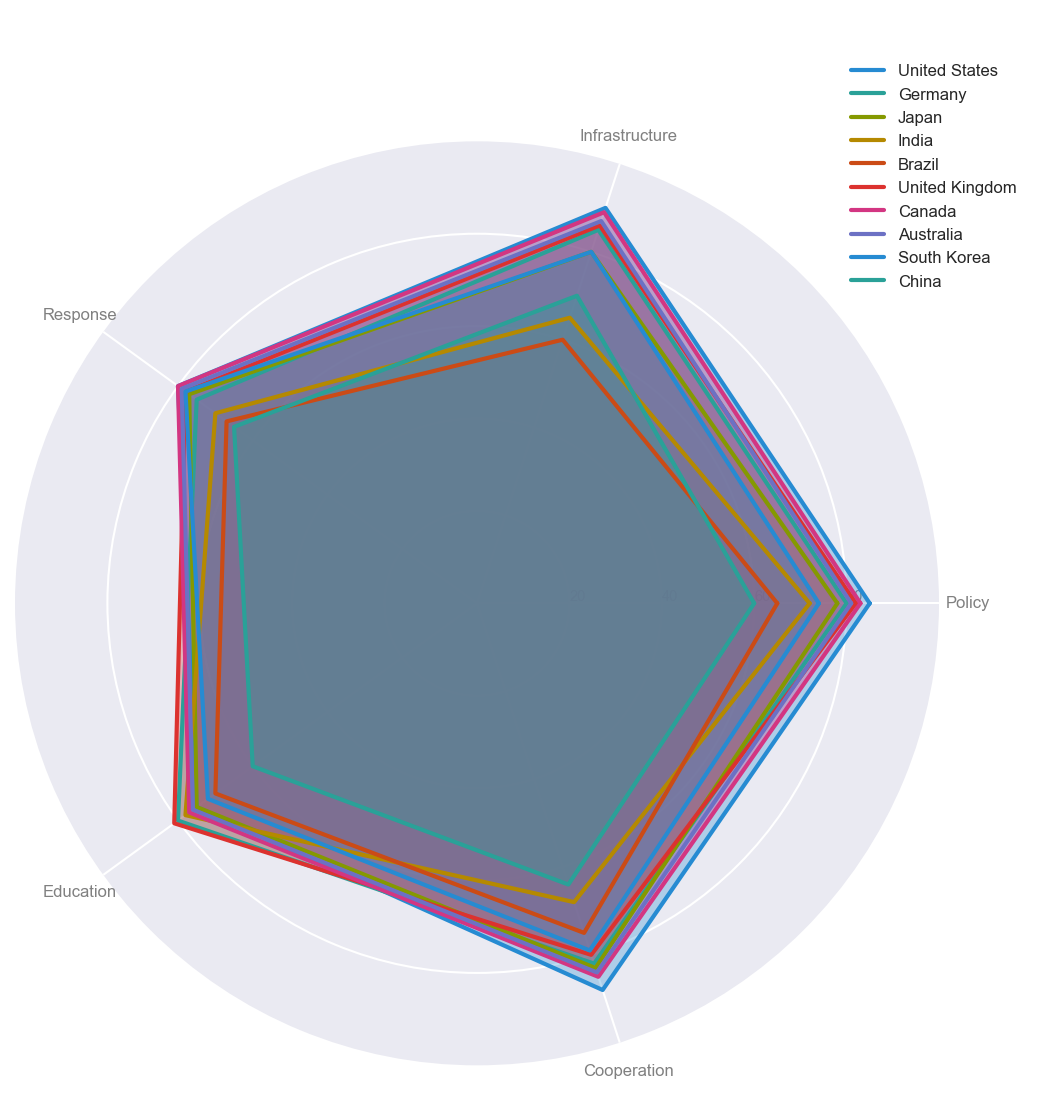Which country has the highest score in Infrastructure? According to the radar chart, the country with the highest score in Infrastructure has the longest spoke extending outwards at the "Infrastructure" axis. By observing the chart, Canada has the highest Infrastructure score.
Answer: Canada Which country scores the lowest in Policy? Identify the country with the shortest spoke on the "Policy" axis. China has the smallest value on this axis.
Answer: China What is the average Education score among all countries? Sum the Education scores of all countries and divide by the number of countries. (75 + 80 + 75 + 78 + 70 + 81 + 77+ 76 + 72 + 60) / 10 = 74.4
Answer: 74.4 Which countries have a higher Response score than Japan? Compare the scores at the "Response" axis where Japan scores 77. The countries with higher scores are United States (80), Germany (80), Canada (80), and Australia (79).
Answer: United States, Germany, Canada, Australia How does the Cooperation score of the United States compare to that of China? Observe the "Cooperation" axis for both United States and China. The United States scores 88, while China scores 64. The United States has a significantly higher Cooperation score compared to China.
Answer: United States scores higher than China What is the difference between the highest and lowest scores in the Policy category? Identify the highest and lowest scores in the Policy category by checking the "Policy" axis. The highest score is 85 (United States), and the lowest is 60 (China). The difference is 85 - 60 = 25.
Answer: 25 Which country has the most balanced scores across all categories? Assess the countries whose spokes are relatively similar in length across all axes, indicating balanced performance. Germany has relatively balanced scores across all categories: Policy (80), Infrastructure (85), Response (75), Education (80), and Cooperation (82).
Answer: Germany How does Brazil's Infrastructure readiness compare to its Response readiness? Compare Brazil's scores on the "Infrastructure" and "Response" axes. Brazil scores 60 on Infrastructure and 67 in Response. Response is higher.
Answer: Response is higher Which country has the lowest score in Cooperation but not in Policy? Identify the country with the lowest score in Cooperation that is not the lowest in Policy. China has the lowest score in Cooperation (64) but not the lowest in Policy (60).
Answer: China 